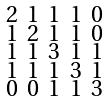<formula> <loc_0><loc_0><loc_500><loc_500>\begin{smallmatrix} 2 & 1 & 1 & 1 & 0 \\ 1 & 2 & 1 & 1 & 0 \\ 1 & 1 & 3 & 1 & 1 \\ 1 & 1 & 1 & 3 & 1 \\ 0 & 0 & 1 & 1 & 3 \end{smallmatrix}</formula> 